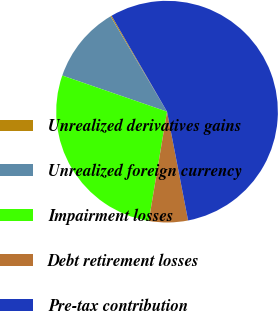<chart> <loc_0><loc_0><loc_500><loc_500><pie_chart><fcel>Unrealized derivatives gains<fcel>Unrealized foreign currency<fcel>Impairment losses<fcel>Debt retirement losses<fcel>Pre-tax contribution<nl><fcel>0.17%<fcel>11.2%<fcel>27.65%<fcel>5.68%<fcel>55.3%<nl></chart> 